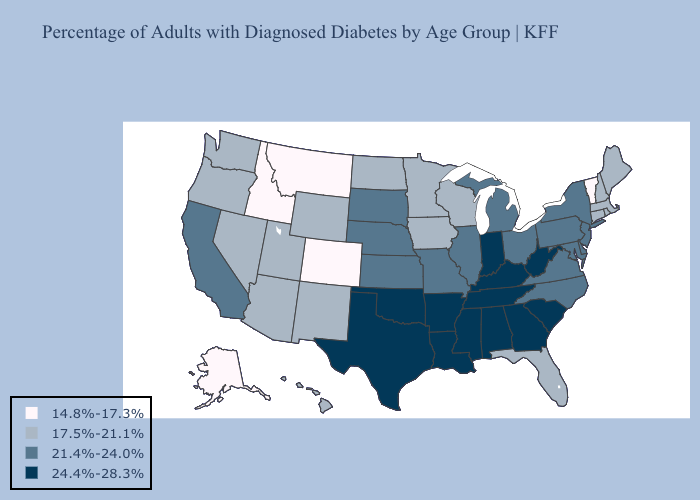What is the value of Idaho?
Keep it brief. 14.8%-17.3%. Name the states that have a value in the range 21.4%-24.0%?
Be succinct. California, Delaware, Illinois, Kansas, Maryland, Michigan, Missouri, Nebraska, New Jersey, New York, North Carolina, Ohio, Pennsylvania, South Dakota, Virginia. Among the states that border Illinois , does Indiana have the lowest value?
Be succinct. No. Does Oklahoma have the same value as Georgia?
Short answer required. Yes. What is the lowest value in the West?
Give a very brief answer. 14.8%-17.3%. Among the states that border Kansas , which have the highest value?
Answer briefly. Oklahoma. Name the states that have a value in the range 14.8%-17.3%?
Short answer required. Alaska, Colorado, Idaho, Montana, Vermont. What is the lowest value in states that border Kentucky?
Write a very short answer. 21.4%-24.0%. What is the value of Montana?
Concise answer only. 14.8%-17.3%. Does the map have missing data?
Write a very short answer. No. What is the highest value in the USA?
Keep it brief. 24.4%-28.3%. Name the states that have a value in the range 14.8%-17.3%?
Give a very brief answer. Alaska, Colorado, Idaho, Montana, Vermont. Does Alabama have the highest value in the USA?
Write a very short answer. Yes. Does the map have missing data?
Answer briefly. No. Among the states that border Connecticut , which have the lowest value?
Quick response, please. Massachusetts, Rhode Island. 